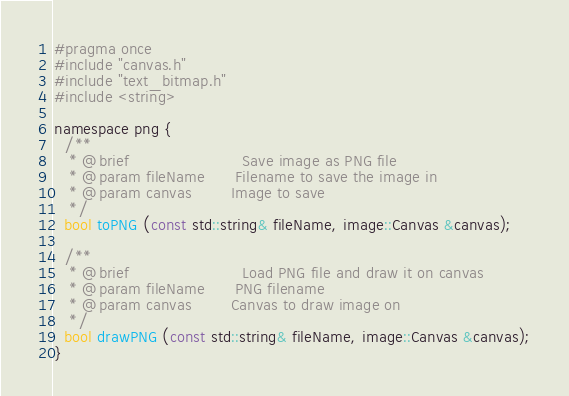<code> <loc_0><loc_0><loc_500><loc_500><_C_>#pragma once
#include "canvas.h"
#include "text_bitmap.h"
#include <string>

namespace png {  
  /**
   * @brief                       Save image as PNG file
   * @param fileName      Filename to save the image in
   * @param canvas        Image to save
   */
  bool toPNG (const std::string& fileName, image::Canvas &canvas);
  
  /**
   * @brief                       Load PNG file and draw it on canvas
   * @param fileName      PNG filename
   * @param canvas        Canvas to draw image on
   */
  bool drawPNG (const std::string& fileName, image::Canvas &canvas);
}
</code> 